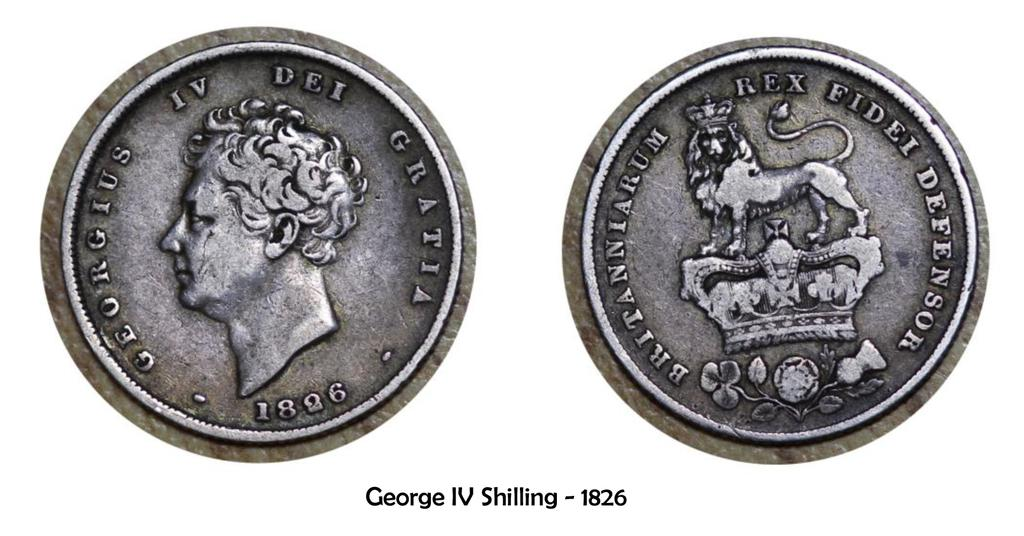<image>
Summarize the visual content of the image. The front and back of a George IV Shilling from 1826 